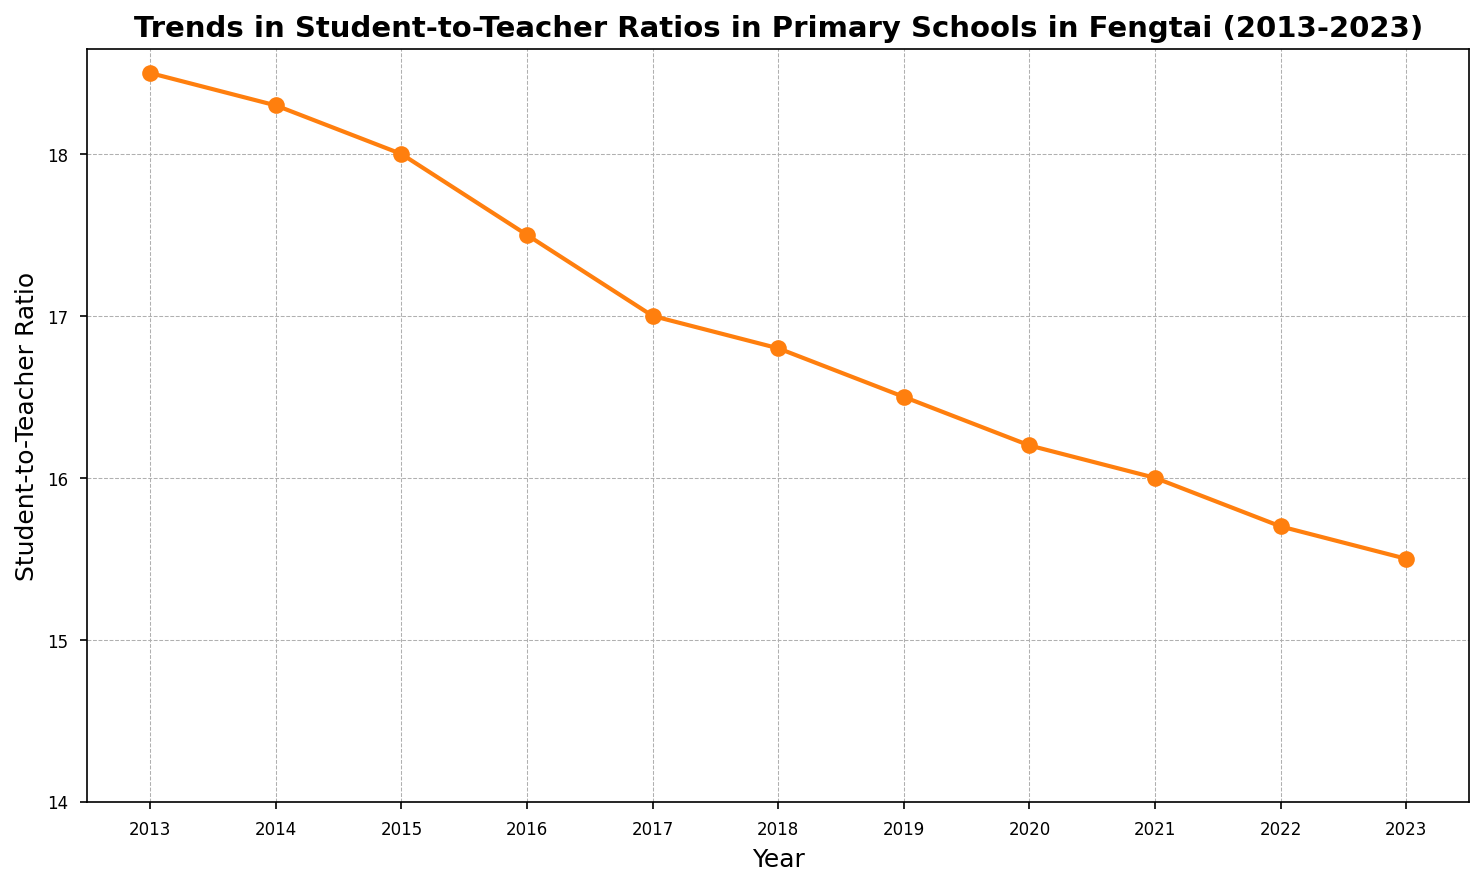What is the trend in the student-to-teacher ratio from 2013 to 2023? The plot shows a consistent decline in the student-to-teacher ratio over the years. By comparing the endpoints, we see the ratio decreases from 18.5 in 2013 to 15.5 in 2023.
Answer: Declining What was the student-to-teacher ratio in 2018? Locate the point corresponding to the year 2018 on the x-axis and observe the value on the y-axis. The ratio is 16.8.
Answer: 16.8 Which year had the highest student-to-teacher ratio? Look for the peak point in the graph. The highest value is at the beginning of the timeline, which corresponds to 2013 with a ratio of 18.5.
Answer: 2013 How much did the student-to-teacher ratio decrease from 2016 to 2023? Subtract the ratio in 2023 from the ratio in 2016. The values are 17.5 in 2016 and 15.5 in 2023, so the decrease is 17.5 - 15.5 = 2.0.
Answer: 2.0 Was the student-to-teacher ratio ever equal to 17.0 in any year? Look along the y-axis for the ratio 17.0 and find the corresponding year on the x-axis. It corresponds to the year 2017.
Answer: 2017 By how much did the student-to-teacher ratio change between 2013 and 2014? Subtract the ratio in 2014 from the ratio in 2013. The values are 18.5 in 2013 and 18.3 in 2014, so the change is 18.5 - 18.3 = 0.2.
Answer: 0.2 What is the average student-to-teacher ratio from 2013 to 2018? First sum up the ratios from 2013 to 2018: 18.5 + 18.3 + 18.0 + 17.5 + 17.0 + 16.8 = 106.1. Then divide by the number of years, which is 6. So, the average is 106.1 / 6 ≈ 17.7.
Answer: 17.7 Which year marked the first significant drop below 18 in the student-to-teacher ratio? Observe the plot and find the year when the ratio first fell below 18. In 2015, the ratio is 18.0, and in 2016, it is 17.5. Therefore, the first significant drop below 18 is in 2015.
Answer: 2015 How many years after 2013 did it take for the ratio to fall below 17? Identify the year when the ratio first falls below 17. The ratio falls to 16.8 in 2018, which is 2018 - 2013 = 5 years after 2013.
Answer: 5 years 